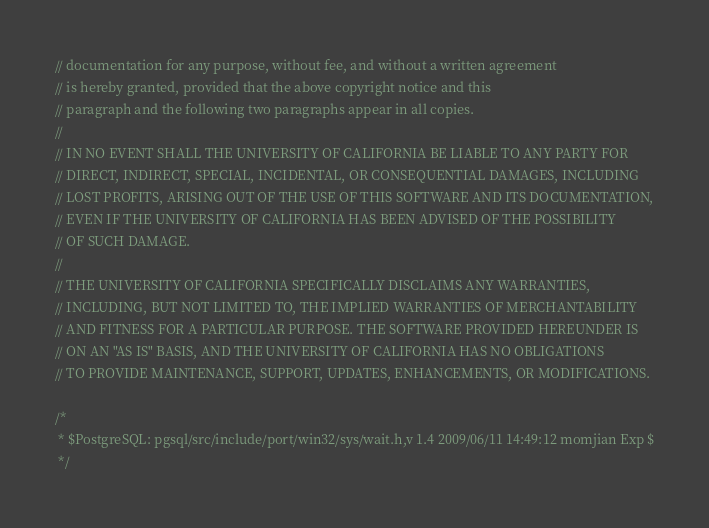<code> <loc_0><loc_0><loc_500><loc_500><_C_>// documentation for any purpose, without fee, and without a written agreement
// is hereby granted, provided that the above copyright notice and this
// paragraph and the following two paragraphs appear in all copies.
//
// IN NO EVENT SHALL THE UNIVERSITY OF CALIFORNIA BE LIABLE TO ANY PARTY FOR
// DIRECT, INDIRECT, SPECIAL, INCIDENTAL, OR CONSEQUENTIAL DAMAGES, INCLUDING
// LOST PROFITS, ARISING OUT OF THE USE OF THIS SOFTWARE AND ITS DOCUMENTATION,
// EVEN IF THE UNIVERSITY OF CALIFORNIA HAS BEEN ADVISED OF THE POSSIBILITY
// OF SUCH DAMAGE.
//
// THE UNIVERSITY OF CALIFORNIA SPECIFICALLY DISCLAIMS ANY WARRANTIES,
// INCLUDING, BUT NOT LIMITED TO, THE IMPLIED WARRANTIES OF MERCHANTABILITY
// AND FITNESS FOR A PARTICULAR PURPOSE. THE SOFTWARE PROVIDED HEREUNDER IS
// ON AN "AS IS" BASIS, AND THE UNIVERSITY OF CALIFORNIA HAS NO OBLIGATIONS
// TO PROVIDE MAINTENANCE, SUPPORT, UPDATES, ENHANCEMENTS, OR MODIFICATIONS.

/*
 * $PostgreSQL: pgsql/src/include/port/win32/sys/wait.h,v 1.4 2009/06/11 14:49:12 momjian Exp $
 */
</code> 